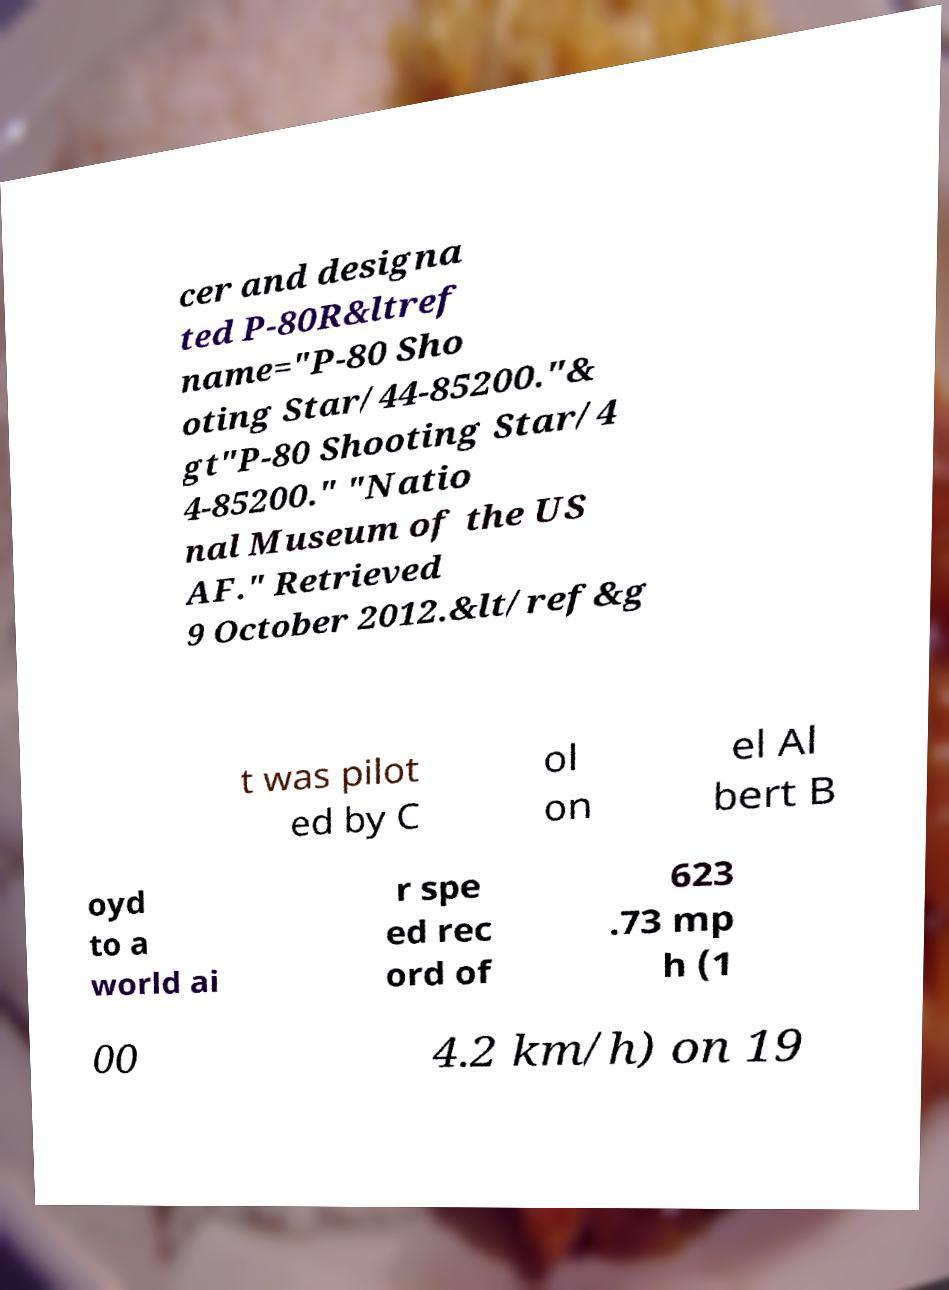Could you assist in decoding the text presented in this image and type it out clearly? cer and designa ted P-80R&ltref name="P-80 Sho oting Star/44-85200."& gt"P-80 Shooting Star/4 4-85200." "Natio nal Museum of the US AF." Retrieved 9 October 2012.&lt/ref&g t was pilot ed by C ol on el Al bert B oyd to a world ai r spe ed rec ord of 623 .73 mp h (1 00 4.2 km/h) on 19 